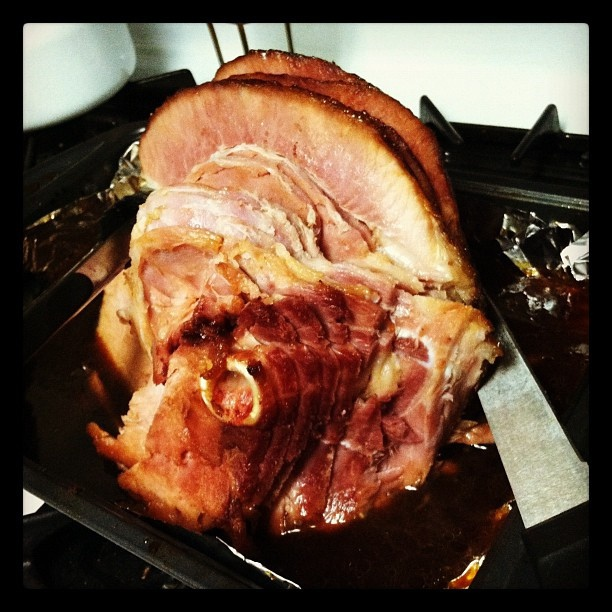Describe the objects in this image and their specific colors. I can see a knife in black, darkgray, beige, and lightgray tones in this image. 